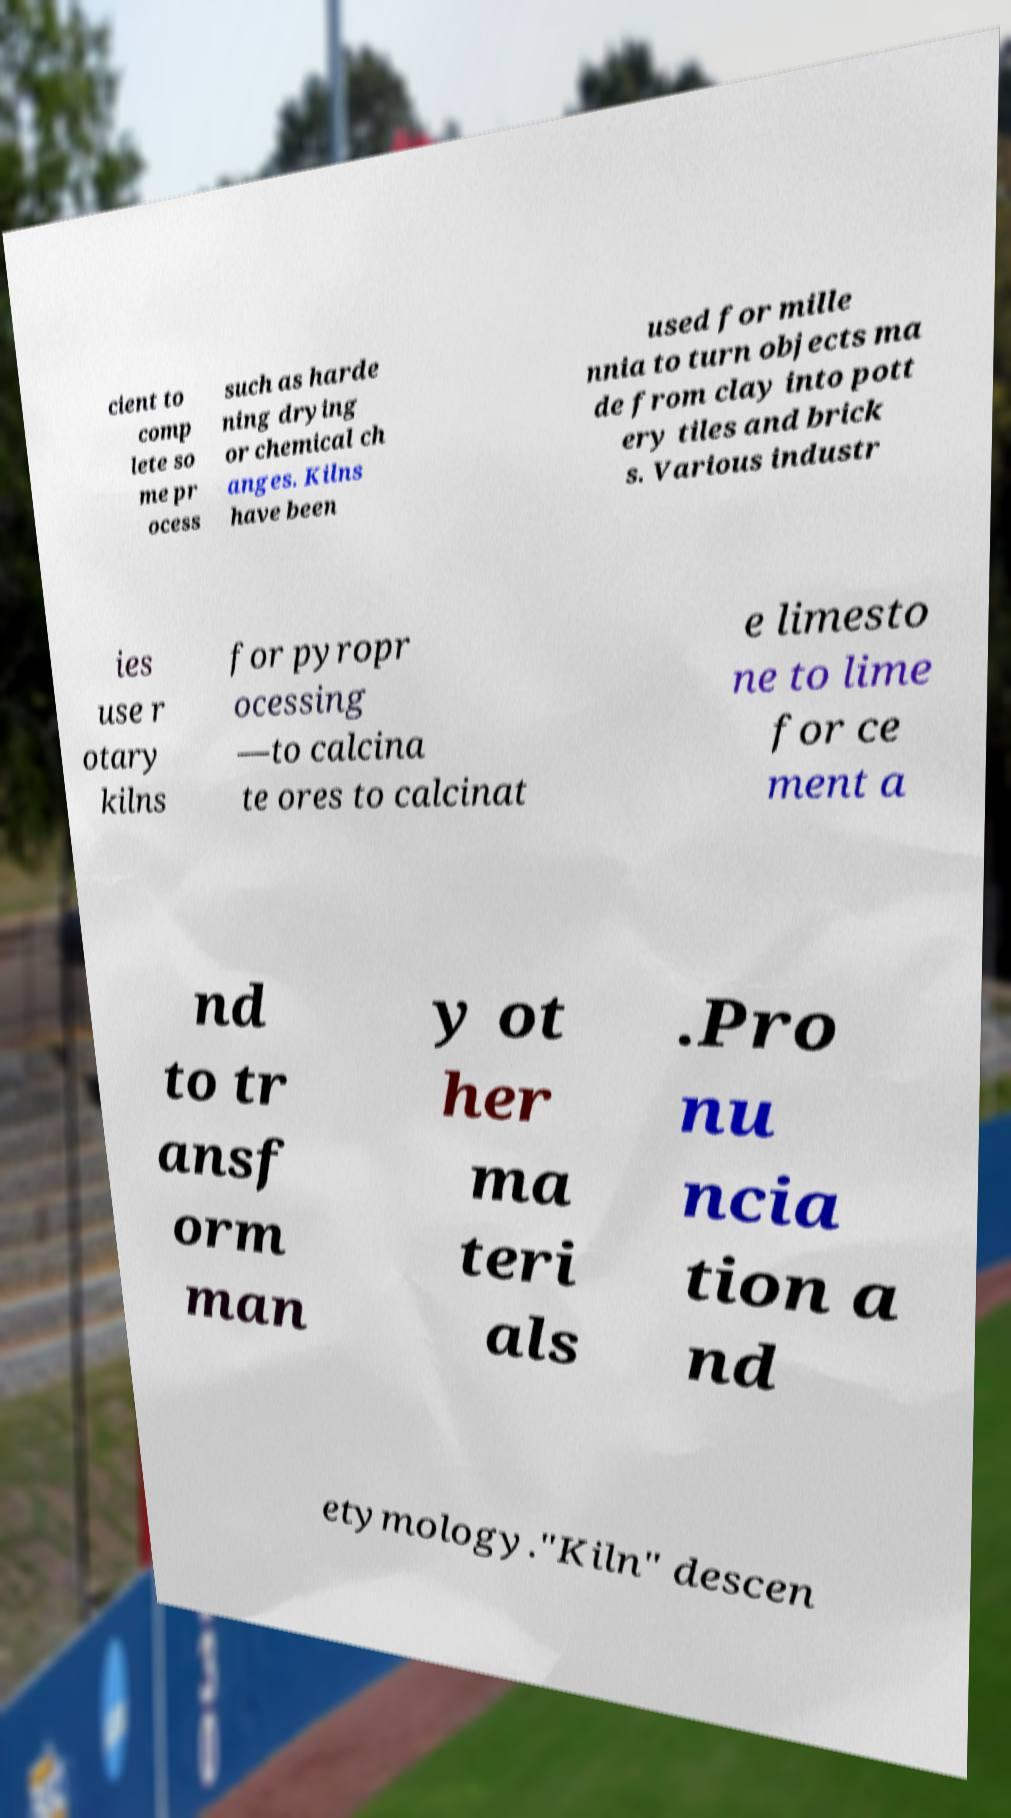Can you accurately transcribe the text from the provided image for me? cient to comp lete so me pr ocess such as harde ning drying or chemical ch anges. Kilns have been used for mille nnia to turn objects ma de from clay into pott ery tiles and brick s. Various industr ies use r otary kilns for pyropr ocessing —to calcina te ores to calcinat e limesto ne to lime for ce ment a nd to tr ansf orm man y ot her ma teri als .Pro nu ncia tion a nd etymology."Kiln" descen 